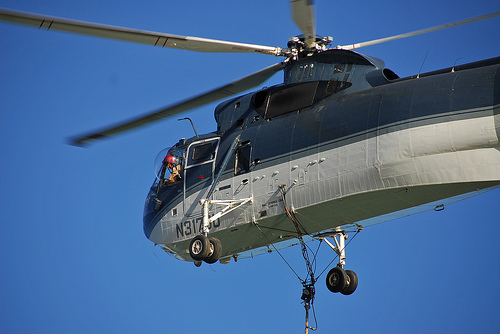<image>
Is there a pilot next to the wheel? No. The pilot is not positioned next to the wheel. They are located in different areas of the scene. 